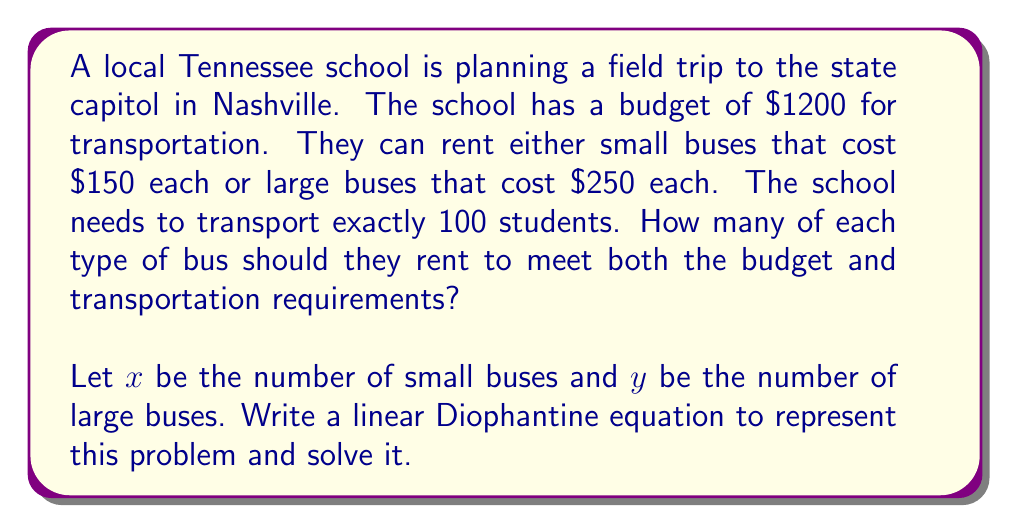Show me your answer to this math problem. Let's approach this step-by-step:

1) First, we need to write two equations based on the given information:

   Budget equation: $150x + 250y = 1200$
   Transportation equation: $15x + 30y = 100$ (assuming small buses seat 15 and large buses seat 30)

2) We'll focus on solving the budget equation as our Diophantine equation:

   $150x + 250y = 1200$

3) Divide all terms by the GCD of the coefficients (50):

   $3x + 5y = 24$

4) We can rewrite this as:

   $3x = 24 - 5y$

5) For this to have integer solutions, the right side must be divisible by 3. So:

   $24 - 5y \equiv 0 \pmod{3}$
   $-5y \equiv 0 \pmod{3}$
   $y \equiv 0 \pmod{3}$

6) This means $y = 3k$ where $k$ is an integer. Substituting back:

   $3x = 24 - 5(3k) = 24 - 15k$
   $x = 8 - 5k$

7) Now we have the general solution:

   $x = 8 - 5k$
   $y = 3k$

   where $k$ is an integer.

8) Given the context, we need non-negative integers. So:

   $8 - 5k \geq 0$ and $3k \geq 0$
   $k \leq 1.6$ and $k \geq 0$

   The only integer value of $k$ that satisfies both is 1.

9) Substituting $k = 1$:

   $x = 8 - 5(1) = 3$
   $y = 3(1) = 3$

10) Verify:
    3 small buses: $3 * 15 = 45$ students
    3 large buses: $3 * 30 = 90$ students
    Total: 45 + 90 = 135 students (meets the requirement of 100+)
    Cost: $3 * 150 + 3 * 250 = 450 + 750 = 1200$ (meets the budget exactly)
Answer: The school should rent 3 small buses and 3 large buses. 